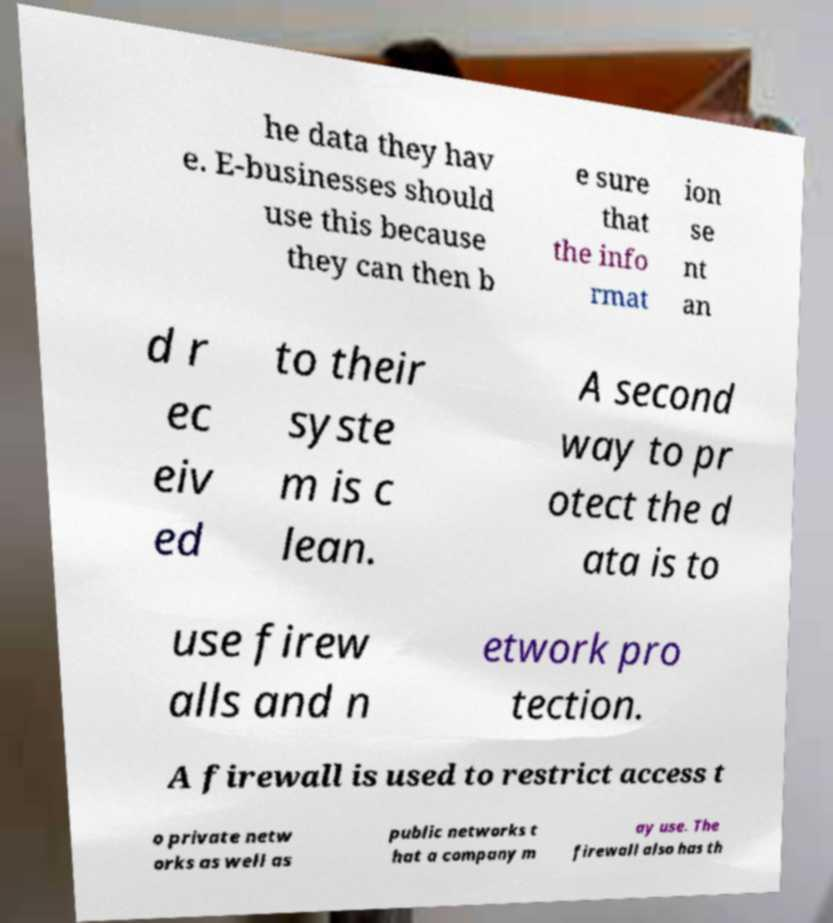Could you extract and type out the text from this image? he data they hav e. E-businesses should use this because they can then b e sure that the info rmat ion se nt an d r ec eiv ed to their syste m is c lean. A second way to pr otect the d ata is to use firew alls and n etwork pro tection. A firewall is used to restrict access t o private netw orks as well as public networks t hat a company m ay use. The firewall also has th 